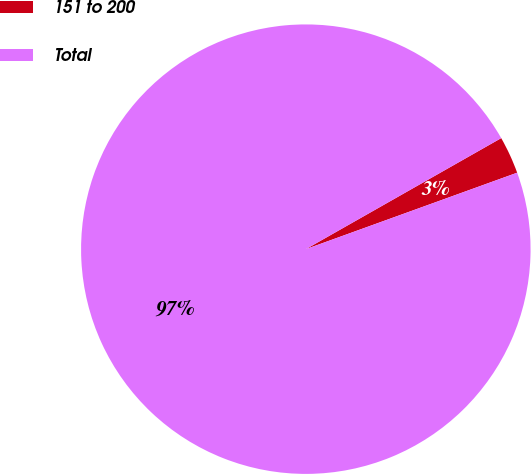Convert chart. <chart><loc_0><loc_0><loc_500><loc_500><pie_chart><fcel>151 to 200<fcel>Total<nl><fcel>2.7%<fcel>97.3%<nl></chart> 